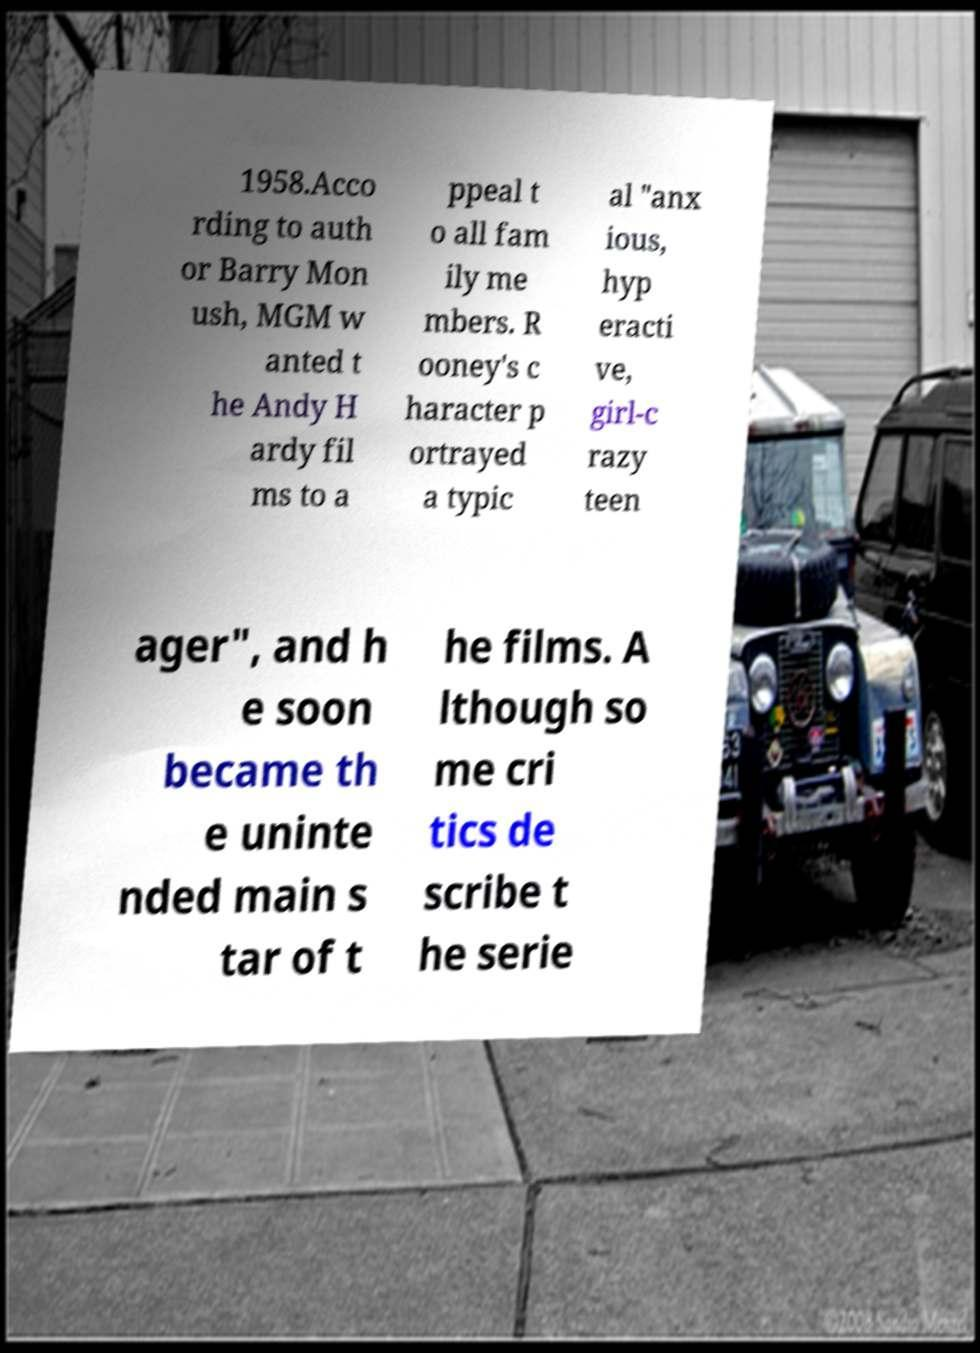What messages or text are displayed in this image? I need them in a readable, typed format. 1958.Acco rding to auth or Barry Mon ush, MGM w anted t he Andy H ardy fil ms to a ppeal t o all fam ily me mbers. R ooney's c haracter p ortrayed a typic al "anx ious, hyp eracti ve, girl-c razy teen ager", and h e soon became th e uninte nded main s tar of t he films. A lthough so me cri tics de scribe t he serie 